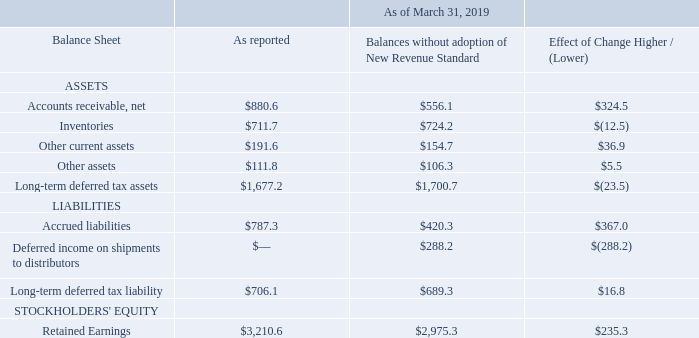Recently Adopted Accounting Pronouncements
On April 1, 2018, the Company adopted ASU 2014-09-Revenue from Contracts with Customers (ASC 606) and all related amendments (“New Revenue Standard”) using the modified retrospective method. The Company has applied the new revenue standard to all contracts that were entered into after adoption and to all contracts that were open as of the initial date of adoption. The Company recognized the cumulative effect of initially applying the new revenue standard as an adjustment to the opening balance of retained earnings. The comparative information has not been restated and continues to be reported under the accounting standards in effect for those periods. The adoption of the new standard impacts the Company's net sales on an ongoing basis depending on the relative amount of revenue sold through its distributors, the change in inventory held by its distributors, and the changes in price concessions granted to its distributors. Previously, the Company deferred revenue and cost of sales on shipments to distributors until the distributor sold the product to their end customer. As required by the new revenue standard, the Company no longer defers revenue and cost of sales, but rather, estimates the effects of returns and allowances provided to distributors and records revenue at the time of sale to the distributor. Sales to non-distributor customers, under both the previous and new revenue standards, are generally recognized upon the Company’s shipment of the product. The cumulative effect of the changes made to the consolidated April 1, 2018 balance sheet for the adoption of the new revenue standard is summarized in the table of opening balance sheet adjustments below. In accordance with the new revenue standard requirements, the disclosure of the impact of adoption on the consolidated income statement and balance sheet for the period ended March 31, 2019 was as follows (in millions):
The significant changes in the financial statements noted in the table above are primarily due to the transition from sellthrough revenue recognition to sell-in revenue recognition as required by the New Revenue Standard, which eliminated the balance of deferred income on shipments to distributors, significantly reduced accounts receivable, and significantly increased retained earnings. Prior to the acquisition of Microsemi, Microsemi already recognized revenue on a sell-in basis, so the impact of the adoption of the New Revenue Standard was primarily driven by Microchip's historical business excluding Microsemi.
What was the main reason given by the company for the significant changes in their financial statements noted in the table? The transition from sellthrough revenue recognition to sell-in revenue recognition as required by the new revenue standard. What was the effect of change in the net accounts receivable?
Answer scale should be: million. 324.5. What was the reported amount of inventories?
Answer scale should be: million. 711.7. What was the difference in reported amounts between net accounts receivable and inventories?
Answer scale should be: million. 880.6-711.7
Answer: 168.9. What was the difference in reported amount between other assets and other current assets?
Answer scale should be: million. 191.6-111.8
Answer: 79.8. What was the Long-term deferred tax liability as a ratio of Accrued liabilities?
Answer scale should be: percent. 706.1/787.3
Answer: 0.9. 